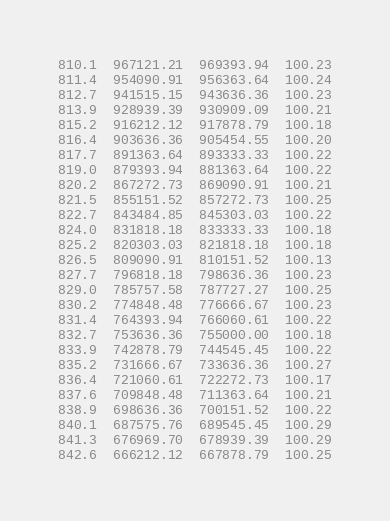<code> <loc_0><loc_0><loc_500><loc_500><_SML_>810.1  967121.21  969393.94  100.23
811.4  954090.91  956363.64  100.24
812.7  941515.15  943636.36  100.23
813.9  928939.39  930909.09  100.21
815.2  916212.12  917878.79  100.18
816.4  903636.36  905454.55  100.20
817.7  891363.64  893333.33  100.22
819.0  879393.94  881363.64  100.22
820.2  867272.73  869090.91  100.21
821.5  855151.52  857272.73  100.25
822.7  843484.85  845303.03  100.22
824.0  831818.18  833333.33  100.18
825.2  820303.03  821818.18  100.18
826.5  809090.91  810151.52  100.13
827.7  796818.18  798636.36  100.23
829.0  785757.58  787727.27  100.25
830.2  774848.48  776666.67  100.23
831.4  764393.94  766060.61  100.22
832.7  753636.36  755000.00  100.18
833.9  742878.79  744545.45  100.22
835.2  731666.67  733636.36  100.27
836.4  721060.61  722272.73  100.17
837.6  709848.48  711363.64  100.21
838.9  698636.36  700151.52  100.22
840.1  687575.76  689545.45  100.29
841.3  676969.70  678939.39  100.29
842.6  666212.12  667878.79  100.25</code> 